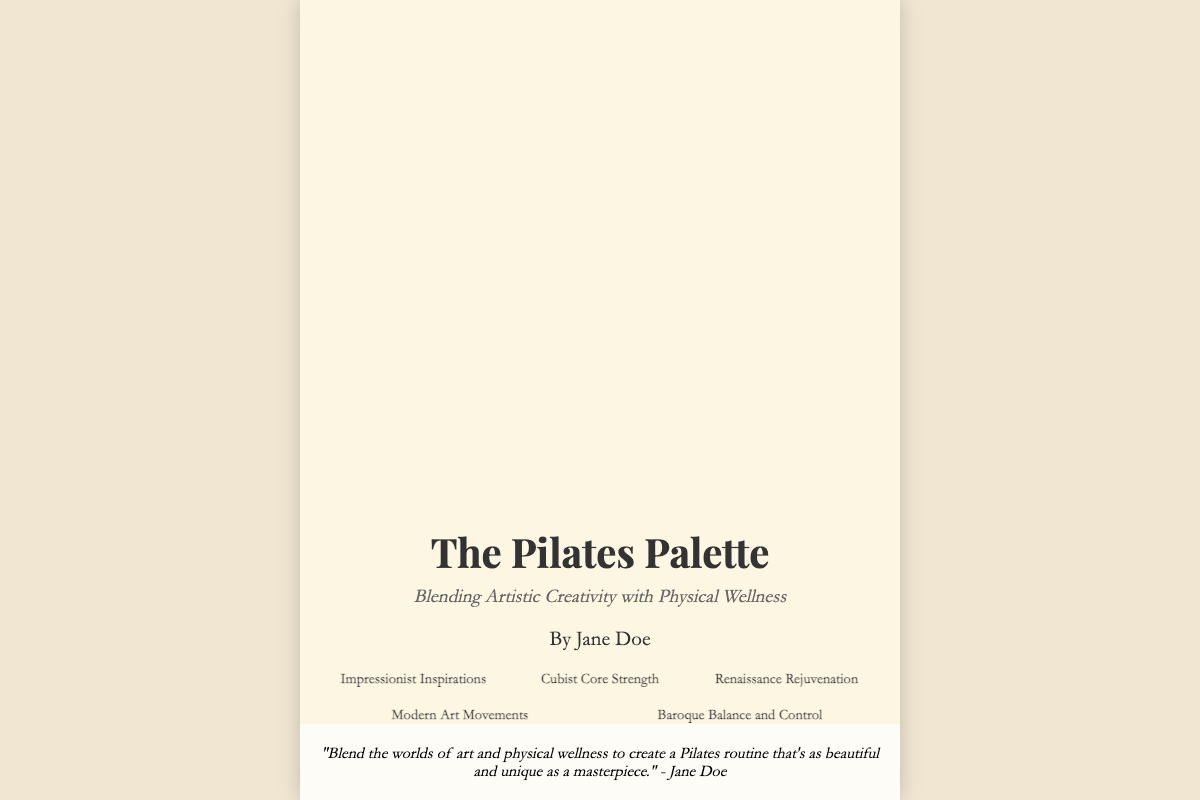What is the title of the book? The title of the book is prominently displayed at the top of the cover.
Answer: The Pilates Palette Who is the author of the book? The author's name is provided in the title section at the bottom of the cover.
Answer: Jane Doe What is the subtitle of the book? The subtitle is placed directly below the title on the cover.
Answer: Blending Artistic Creativity with Physical Wellness How many sections are listed on the cover? The number of sections can be counted in the sections area of the cover.
Answer: Five What is one of the section headings? Section headings are provided in the sections area; any heading can be chosen.
Answer: Impressionist Inspirations What type of artistic styles does the book explore? The book cover mentions the blending of art with Pilates, suggesting various artistic styles.
Answer: Artistic styles What is the primary focus of the book? The overall theme of the book is evident in both the title and subtitle.
Answer: Physical wellness What quote is featured on the cover? A quote from the author is at the bottom and encapsulates the book's theme.
Answer: "Blend the worlds of art and physical wellness to create a Pilates routine that's as beautiful and unique as a masterpiece." - Jane Doe What colors dominate the book cover design? The background colors and font colors can be observed directly from the visual details.
Answer: Cream and pastel colors 